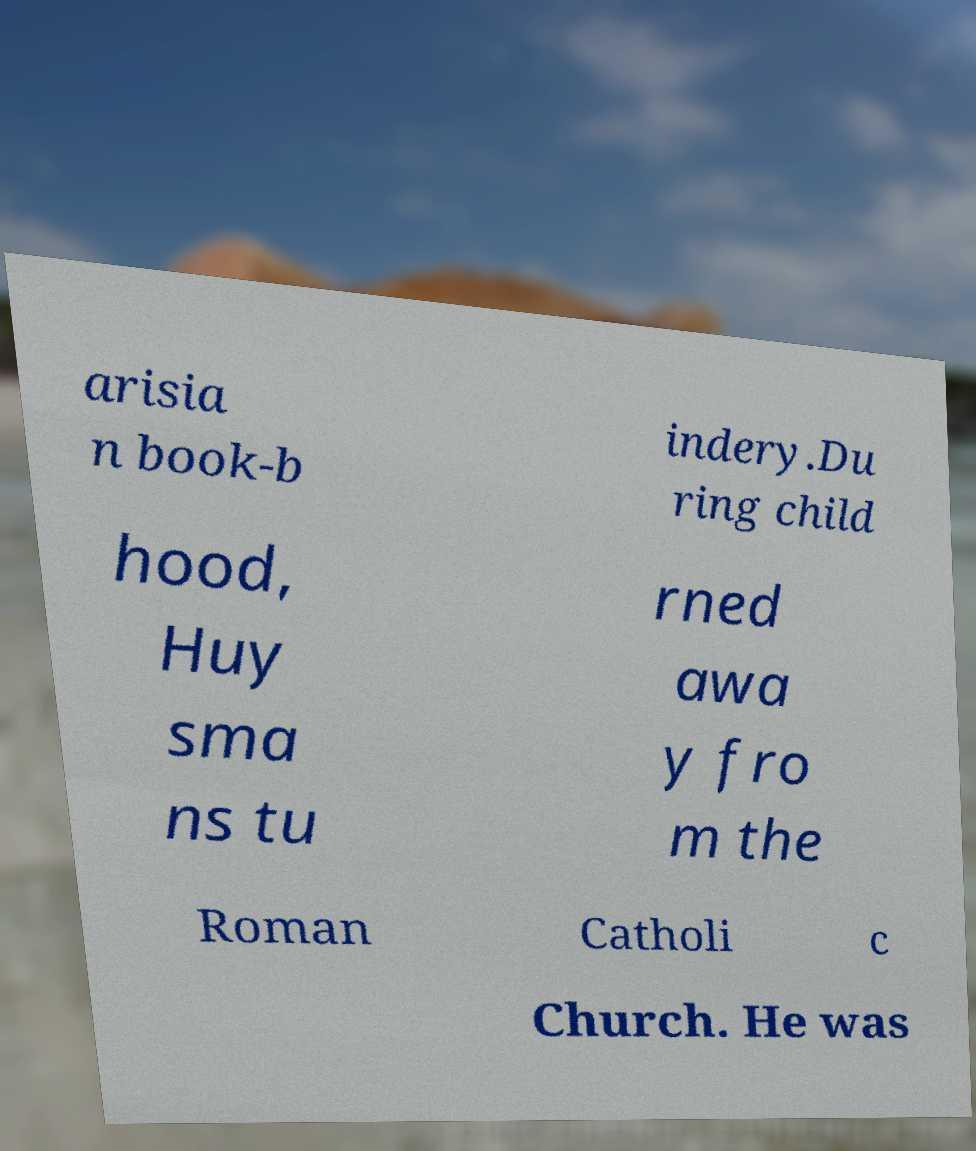I need the written content from this picture converted into text. Can you do that? arisia n book-b indery.Du ring child hood, Huy sma ns tu rned awa y fro m the Roman Catholi c Church. He was 